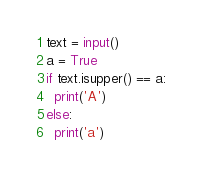Convert code to text. <code><loc_0><loc_0><loc_500><loc_500><_Python_>text = input()
a = True
if text.isupper() == a:
  print('A')
else:
  print('a')</code> 